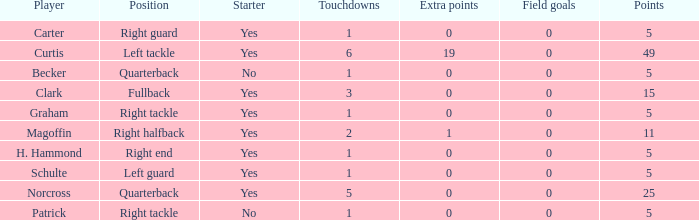Name the number of field goals for 19 extra points 1.0. 